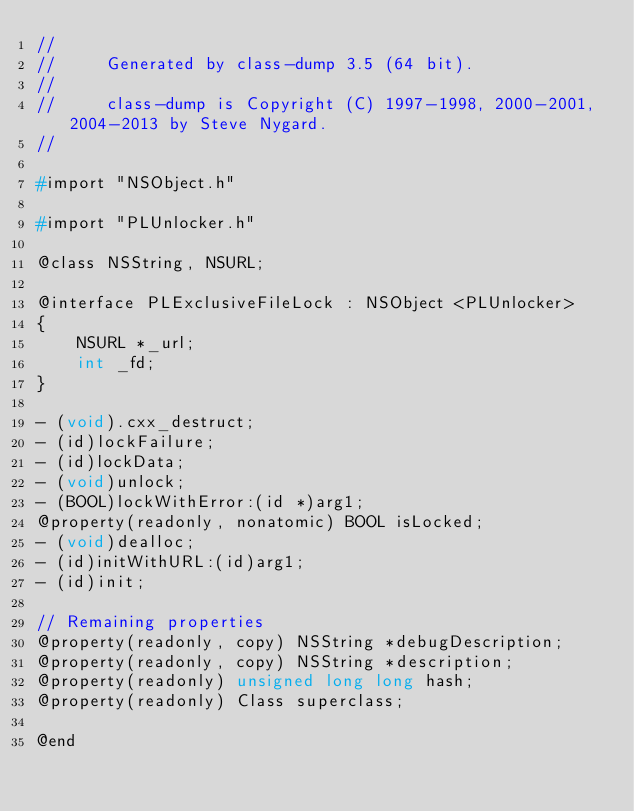<code> <loc_0><loc_0><loc_500><loc_500><_C_>//
//     Generated by class-dump 3.5 (64 bit).
//
//     class-dump is Copyright (C) 1997-1998, 2000-2001, 2004-2013 by Steve Nygard.
//

#import "NSObject.h"

#import "PLUnlocker.h"

@class NSString, NSURL;

@interface PLExclusiveFileLock : NSObject <PLUnlocker>
{
    NSURL *_url;
    int _fd;
}

- (void).cxx_destruct;
- (id)lockFailure;
- (id)lockData;
- (void)unlock;
- (BOOL)lockWithError:(id *)arg1;
@property(readonly, nonatomic) BOOL isLocked;
- (void)dealloc;
- (id)initWithURL:(id)arg1;
- (id)init;

// Remaining properties
@property(readonly, copy) NSString *debugDescription;
@property(readonly, copy) NSString *description;
@property(readonly) unsigned long long hash;
@property(readonly) Class superclass;

@end

</code> 